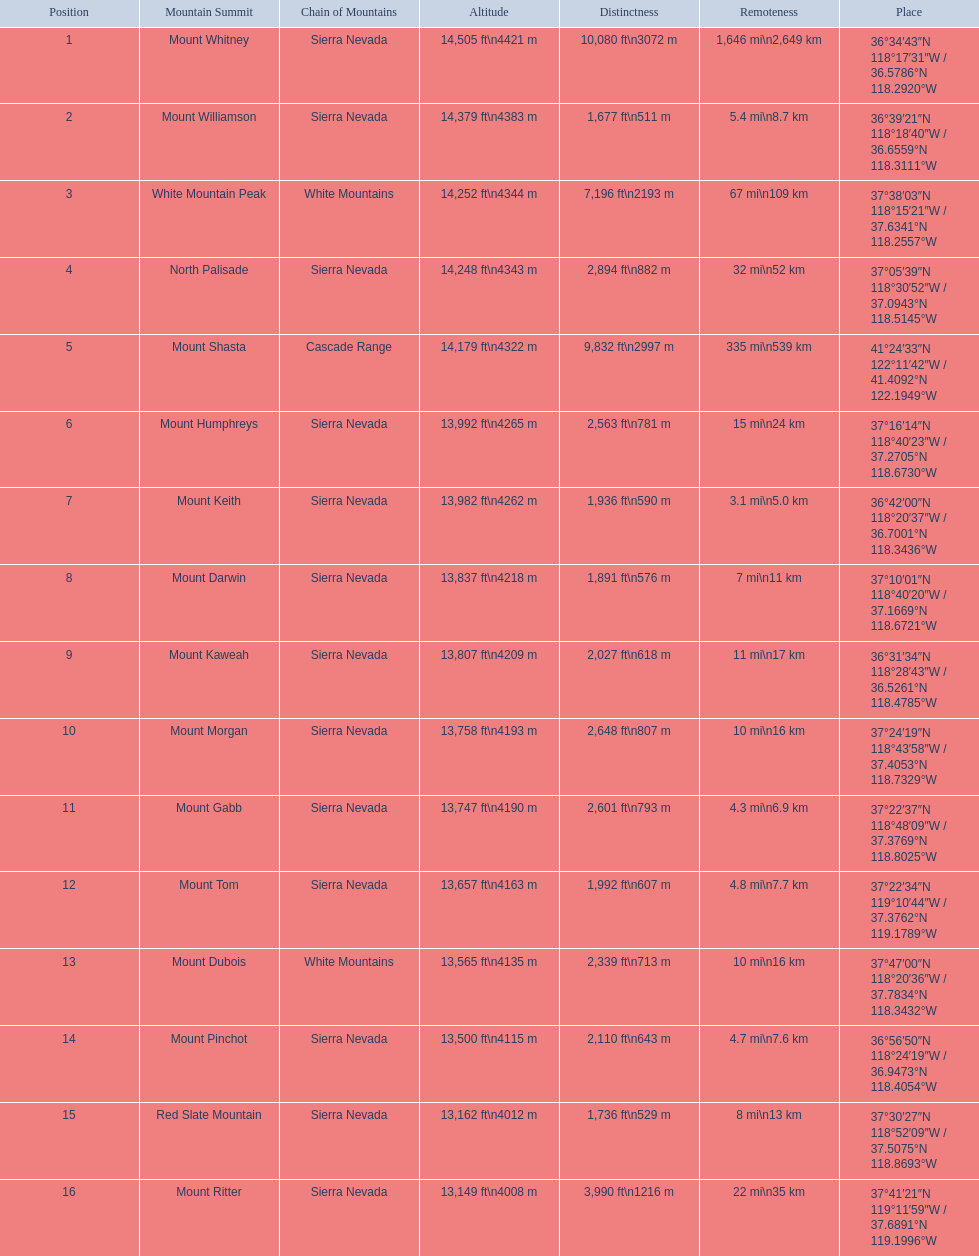What are the heights of the peaks? 14,505 ft\n4421 m, 14,379 ft\n4383 m, 14,252 ft\n4344 m, 14,248 ft\n4343 m, 14,179 ft\n4322 m, 13,992 ft\n4265 m, 13,982 ft\n4262 m, 13,837 ft\n4218 m, 13,807 ft\n4209 m, 13,758 ft\n4193 m, 13,747 ft\n4190 m, 13,657 ft\n4163 m, 13,565 ft\n4135 m, 13,500 ft\n4115 m, 13,162 ft\n4012 m, 13,149 ft\n4008 m. Which of these heights is tallest? 14,505 ft\n4421 m. What peak is 14,505 feet? Mount Whitney. 